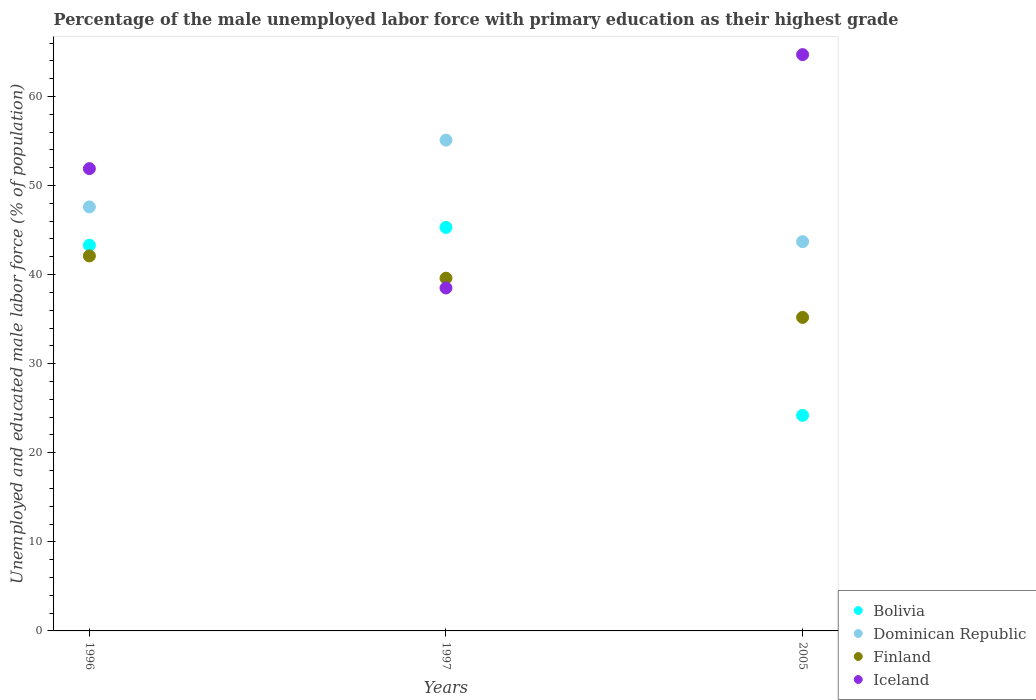How many different coloured dotlines are there?
Your response must be concise. 4. Is the number of dotlines equal to the number of legend labels?
Offer a very short reply. Yes. What is the percentage of the unemployed male labor force with primary education in Bolivia in 2005?
Ensure brevity in your answer.  24.2. Across all years, what is the maximum percentage of the unemployed male labor force with primary education in Bolivia?
Offer a terse response. 45.3. Across all years, what is the minimum percentage of the unemployed male labor force with primary education in Iceland?
Make the answer very short. 38.5. In which year was the percentage of the unemployed male labor force with primary education in Iceland maximum?
Your answer should be compact. 2005. In which year was the percentage of the unemployed male labor force with primary education in Iceland minimum?
Make the answer very short. 1997. What is the total percentage of the unemployed male labor force with primary education in Bolivia in the graph?
Offer a very short reply. 112.8. What is the difference between the percentage of the unemployed male labor force with primary education in Finland in 1996 and that in 2005?
Your answer should be compact. 6.9. What is the difference between the percentage of the unemployed male labor force with primary education in Iceland in 2005 and the percentage of the unemployed male labor force with primary education in Finland in 1996?
Your answer should be compact. 22.6. What is the average percentage of the unemployed male labor force with primary education in Bolivia per year?
Offer a terse response. 37.6. In the year 1996, what is the difference between the percentage of the unemployed male labor force with primary education in Finland and percentage of the unemployed male labor force with primary education in Bolivia?
Your response must be concise. -1.2. In how many years, is the percentage of the unemployed male labor force with primary education in Iceland greater than 30 %?
Your answer should be very brief. 3. What is the ratio of the percentage of the unemployed male labor force with primary education in Finland in 1996 to that in 1997?
Your answer should be compact. 1.06. Is the percentage of the unemployed male labor force with primary education in Iceland in 1997 less than that in 2005?
Keep it short and to the point. Yes. What is the difference between the highest and the second highest percentage of the unemployed male labor force with primary education in Bolivia?
Provide a short and direct response. 2. What is the difference between the highest and the lowest percentage of the unemployed male labor force with primary education in Dominican Republic?
Offer a very short reply. 11.4. Is the sum of the percentage of the unemployed male labor force with primary education in Finland in 1997 and 2005 greater than the maximum percentage of the unemployed male labor force with primary education in Iceland across all years?
Ensure brevity in your answer.  Yes. Is the percentage of the unemployed male labor force with primary education in Finland strictly less than the percentage of the unemployed male labor force with primary education in Iceland over the years?
Your answer should be compact. No. How many dotlines are there?
Provide a short and direct response. 4. Does the graph contain any zero values?
Provide a succinct answer. No. Where does the legend appear in the graph?
Your answer should be compact. Bottom right. How are the legend labels stacked?
Ensure brevity in your answer.  Vertical. What is the title of the graph?
Your answer should be compact. Percentage of the male unemployed labor force with primary education as their highest grade. What is the label or title of the Y-axis?
Keep it short and to the point. Unemployed and educated male labor force (% of population). What is the Unemployed and educated male labor force (% of population) in Bolivia in 1996?
Offer a very short reply. 43.3. What is the Unemployed and educated male labor force (% of population) in Dominican Republic in 1996?
Offer a terse response. 47.6. What is the Unemployed and educated male labor force (% of population) in Finland in 1996?
Make the answer very short. 42.1. What is the Unemployed and educated male labor force (% of population) of Iceland in 1996?
Offer a very short reply. 51.9. What is the Unemployed and educated male labor force (% of population) in Bolivia in 1997?
Your response must be concise. 45.3. What is the Unemployed and educated male labor force (% of population) in Dominican Republic in 1997?
Make the answer very short. 55.1. What is the Unemployed and educated male labor force (% of population) of Finland in 1997?
Ensure brevity in your answer.  39.6. What is the Unemployed and educated male labor force (% of population) of Iceland in 1997?
Offer a terse response. 38.5. What is the Unemployed and educated male labor force (% of population) in Bolivia in 2005?
Your answer should be very brief. 24.2. What is the Unemployed and educated male labor force (% of population) of Dominican Republic in 2005?
Offer a terse response. 43.7. What is the Unemployed and educated male labor force (% of population) of Finland in 2005?
Provide a succinct answer. 35.2. What is the Unemployed and educated male labor force (% of population) of Iceland in 2005?
Offer a terse response. 64.7. Across all years, what is the maximum Unemployed and educated male labor force (% of population) in Bolivia?
Offer a terse response. 45.3. Across all years, what is the maximum Unemployed and educated male labor force (% of population) of Dominican Republic?
Keep it short and to the point. 55.1. Across all years, what is the maximum Unemployed and educated male labor force (% of population) of Finland?
Make the answer very short. 42.1. Across all years, what is the maximum Unemployed and educated male labor force (% of population) of Iceland?
Provide a succinct answer. 64.7. Across all years, what is the minimum Unemployed and educated male labor force (% of population) in Bolivia?
Your response must be concise. 24.2. Across all years, what is the minimum Unemployed and educated male labor force (% of population) of Dominican Republic?
Offer a very short reply. 43.7. Across all years, what is the minimum Unemployed and educated male labor force (% of population) of Finland?
Provide a short and direct response. 35.2. Across all years, what is the minimum Unemployed and educated male labor force (% of population) of Iceland?
Give a very brief answer. 38.5. What is the total Unemployed and educated male labor force (% of population) of Bolivia in the graph?
Offer a very short reply. 112.8. What is the total Unemployed and educated male labor force (% of population) in Dominican Republic in the graph?
Provide a short and direct response. 146.4. What is the total Unemployed and educated male labor force (% of population) in Finland in the graph?
Your answer should be very brief. 116.9. What is the total Unemployed and educated male labor force (% of population) of Iceland in the graph?
Your response must be concise. 155.1. What is the difference between the Unemployed and educated male labor force (% of population) of Bolivia in 1996 and that in 2005?
Keep it short and to the point. 19.1. What is the difference between the Unemployed and educated male labor force (% of population) in Dominican Republic in 1996 and that in 2005?
Make the answer very short. 3.9. What is the difference between the Unemployed and educated male labor force (% of population) in Iceland in 1996 and that in 2005?
Give a very brief answer. -12.8. What is the difference between the Unemployed and educated male labor force (% of population) in Bolivia in 1997 and that in 2005?
Give a very brief answer. 21.1. What is the difference between the Unemployed and educated male labor force (% of population) in Iceland in 1997 and that in 2005?
Your response must be concise. -26.2. What is the difference between the Unemployed and educated male labor force (% of population) of Bolivia in 1996 and the Unemployed and educated male labor force (% of population) of Dominican Republic in 1997?
Ensure brevity in your answer.  -11.8. What is the difference between the Unemployed and educated male labor force (% of population) of Bolivia in 1996 and the Unemployed and educated male labor force (% of population) of Finland in 1997?
Provide a short and direct response. 3.7. What is the difference between the Unemployed and educated male labor force (% of population) of Bolivia in 1996 and the Unemployed and educated male labor force (% of population) of Iceland in 2005?
Your answer should be very brief. -21.4. What is the difference between the Unemployed and educated male labor force (% of population) in Dominican Republic in 1996 and the Unemployed and educated male labor force (% of population) in Finland in 2005?
Give a very brief answer. 12.4. What is the difference between the Unemployed and educated male labor force (% of population) of Dominican Republic in 1996 and the Unemployed and educated male labor force (% of population) of Iceland in 2005?
Your response must be concise. -17.1. What is the difference between the Unemployed and educated male labor force (% of population) of Finland in 1996 and the Unemployed and educated male labor force (% of population) of Iceland in 2005?
Your answer should be very brief. -22.6. What is the difference between the Unemployed and educated male labor force (% of population) of Bolivia in 1997 and the Unemployed and educated male labor force (% of population) of Dominican Republic in 2005?
Make the answer very short. 1.6. What is the difference between the Unemployed and educated male labor force (% of population) in Bolivia in 1997 and the Unemployed and educated male labor force (% of population) in Finland in 2005?
Make the answer very short. 10.1. What is the difference between the Unemployed and educated male labor force (% of population) of Bolivia in 1997 and the Unemployed and educated male labor force (% of population) of Iceland in 2005?
Your answer should be compact. -19.4. What is the difference between the Unemployed and educated male labor force (% of population) of Dominican Republic in 1997 and the Unemployed and educated male labor force (% of population) of Iceland in 2005?
Provide a short and direct response. -9.6. What is the difference between the Unemployed and educated male labor force (% of population) in Finland in 1997 and the Unemployed and educated male labor force (% of population) in Iceland in 2005?
Ensure brevity in your answer.  -25.1. What is the average Unemployed and educated male labor force (% of population) in Bolivia per year?
Ensure brevity in your answer.  37.6. What is the average Unemployed and educated male labor force (% of population) in Dominican Republic per year?
Offer a terse response. 48.8. What is the average Unemployed and educated male labor force (% of population) of Finland per year?
Your answer should be very brief. 38.97. What is the average Unemployed and educated male labor force (% of population) in Iceland per year?
Offer a terse response. 51.7. In the year 1996, what is the difference between the Unemployed and educated male labor force (% of population) of Bolivia and Unemployed and educated male labor force (% of population) of Dominican Republic?
Your answer should be compact. -4.3. In the year 1996, what is the difference between the Unemployed and educated male labor force (% of population) of Bolivia and Unemployed and educated male labor force (% of population) of Iceland?
Make the answer very short. -8.6. In the year 1996, what is the difference between the Unemployed and educated male labor force (% of population) in Dominican Republic and Unemployed and educated male labor force (% of population) in Iceland?
Provide a succinct answer. -4.3. In the year 1996, what is the difference between the Unemployed and educated male labor force (% of population) of Finland and Unemployed and educated male labor force (% of population) of Iceland?
Your response must be concise. -9.8. In the year 1997, what is the difference between the Unemployed and educated male labor force (% of population) in Bolivia and Unemployed and educated male labor force (% of population) in Finland?
Offer a very short reply. 5.7. In the year 1997, what is the difference between the Unemployed and educated male labor force (% of population) in Bolivia and Unemployed and educated male labor force (% of population) in Iceland?
Keep it short and to the point. 6.8. In the year 1997, what is the difference between the Unemployed and educated male labor force (% of population) of Dominican Republic and Unemployed and educated male labor force (% of population) of Iceland?
Make the answer very short. 16.6. In the year 1997, what is the difference between the Unemployed and educated male labor force (% of population) in Finland and Unemployed and educated male labor force (% of population) in Iceland?
Ensure brevity in your answer.  1.1. In the year 2005, what is the difference between the Unemployed and educated male labor force (% of population) in Bolivia and Unemployed and educated male labor force (% of population) in Dominican Republic?
Make the answer very short. -19.5. In the year 2005, what is the difference between the Unemployed and educated male labor force (% of population) in Bolivia and Unemployed and educated male labor force (% of population) in Iceland?
Keep it short and to the point. -40.5. In the year 2005, what is the difference between the Unemployed and educated male labor force (% of population) of Finland and Unemployed and educated male labor force (% of population) of Iceland?
Make the answer very short. -29.5. What is the ratio of the Unemployed and educated male labor force (% of population) of Bolivia in 1996 to that in 1997?
Ensure brevity in your answer.  0.96. What is the ratio of the Unemployed and educated male labor force (% of population) in Dominican Republic in 1996 to that in 1997?
Ensure brevity in your answer.  0.86. What is the ratio of the Unemployed and educated male labor force (% of population) in Finland in 1996 to that in 1997?
Offer a terse response. 1.06. What is the ratio of the Unemployed and educated male labor force (% of population) in Iceland in 1996 to that in 1997?
Ensure brevity in your answer.  1.35. What is the ratio of the Unemployed and educated male labor force (% of population) in Bolivia in 1996 to that in 2005?
Your answer should be very brief. 1.79. What is the ratio of the Unemployed and educated male labor force (% of population) in Dominican Republic in 1996 to that in 2005?
Provide a succinct answer. 1.09. What is the ratio of the Unemployed and educated male labor force (% of population) in Finland in 1996 to that in 2005?
Offer a very short reply. 1.2. What is the ratio of the Unemployed and educated male labor force (% of population) in Iceland in 1996 to that in 2005?
Offer a very short reply. 0.8. What is the ratio of the Unemployed and educated male labor force (% of population) in Bolivia in 1997 to that in 2005?
Provide a short and direct response. 1.87. What is the ratio of the Unemployed and educated male labor force (% of population) of Dominican Republic in 1997 to that in 2005?
Your response must be concise. 1.26. What is the ratio of the Unemployed and educated male labor force (% of population) of Finland in 1997 to that in 2005?
Provide a succinct answer. 1.12. What is the ratio of the Unemployed and educated male labor force (% of population) of Iceland in 1997 to that in 2005?
Give a very brief answer. 0.6. What is the difference between the highest and the second highest Unemployed and educated male labor force (% of population) in Bolivia?
Your answer should be compact. 2. What is the difference between the highest and the second highest Unemployed and educated male labor force (% of population) of Dominican Republic?
Keep it short and to the point. 7.5. What is the difference between the highest and the lowest Unemployed and educated male labor force (% of population) of Bolivia?
Offer a terse response. 21.1. What is the difference between the highest and the lowest Unemployed and educated male labor force (% of population) of Dominican Republic?
Offer a terse response. 11.4. What is the difference between the highest and the lowest Unemployed and educated male labor force (% of population) in Iceland?
Your answer should be very brief. 26.2. 